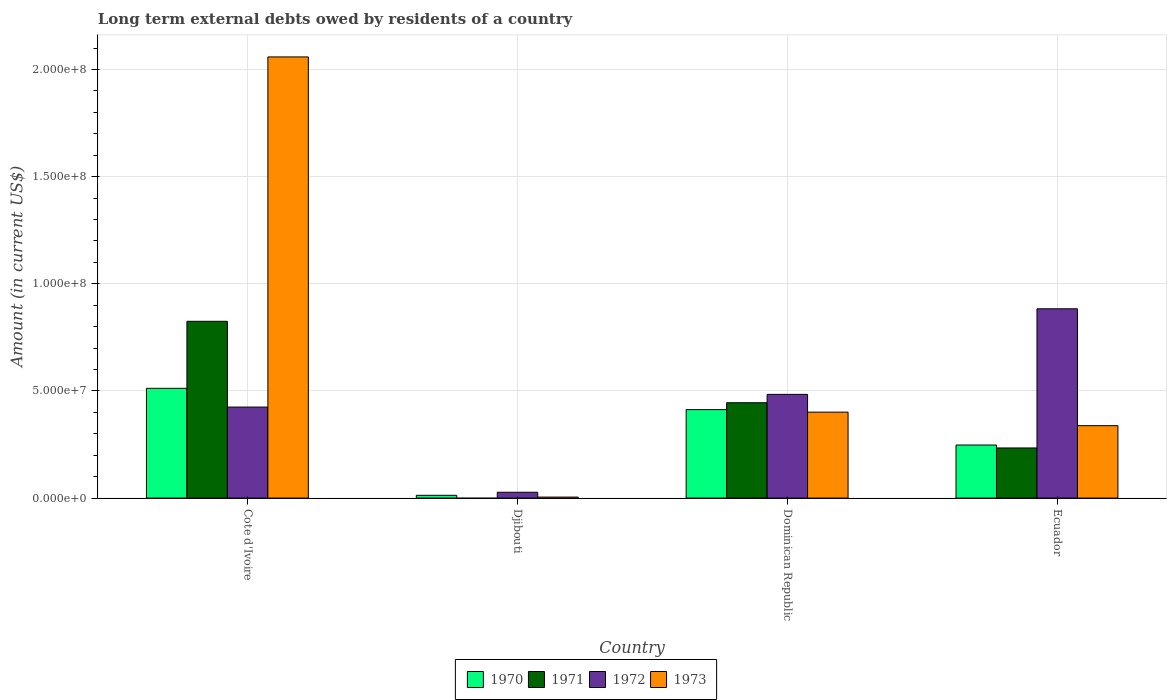Are the number of bars per tick equal to the number of legend labels?
Provide a succinct answer. No. What is the label of the 1st group of bars from the left?
Your answer should be very brief. Cote d'Ivoire. What is the amount of long-term external debts owed by residents in 1973 in Ecuador?
Keep it short and to the point. 3.38e+07. Across all countries, what is the maximum amount of long-term external debts owed by residents in 1971?
Your answer should be compact. 8.25e+07. Across all countries, what is the minimum amount of long-term external debts owed by residents in 1972?
Offer a very short reply. 2.72e+06. In which country was the amount of long-term external debts owed by residents in 1973 maximum?
Provide a short and direct response. Cote d'Ivoire. What is the total amount of long-term external debts owed by residents in 1971 in the graph?
Make the answer very short. 1.50e+08. What is the difference between the amount of long-term external debts owed by residents in 1973 in Cote d'Ivoire and that in Djibouti?
Offer a very short reply. 2.05e+08. What is the difference between the amount of long-term external debts owed by residents in 1972 in Djibouti and the amount of long-term external debts owed by residents in 1970 in Dominican Republic?
Ensure brevity in your answer.  -3.86e+07. What is the average amount of long-term external debts owed by residents in 1970 per country?
Make the answer very short. 2.96e+07. What is the difference between the amount of long-term external debts owed by residents of/in 1970 and amount of long-term external debts owed by residents of/in 1973 in Djibouti?
Make the answer very short. 8.32e+05. What is the ratio of the amount of long-term external debts owed by residents in 1973 in Dominican Republic to that in Ecuador?
Provide a succinct answer. 1.19. Is the difference between the amount of long-term external debts owed by residents in 1970 in Cote d'Ivoire and Djibouti greater than the difference between the amount of long-term external debts owed by residents in 1973 in Cote d'Ivoire and Djibouti?
Your answer should be very brief. No. What is the difference between the highest and the second highest amount of long-term external debts owed by residents in 1971?
Offer a very short reply. 5.91e+07. What is the difference between the highest and the lowest amount of long-term external debts owed by residents in 1970?
Give a very brief answer. 4.99e+07. Is the sum of the amount of long-term external debts owed by residents in 1970 in Djibouti and Dominican Republic greater than the maximum amount of long-term external debts owed by residents in 1971 across all countries?
Offer a very short reply. No. How many bars are there?
Your answer should be compact. 15. Are all the bars in the graph horizontal?
Offer a very short reply. No. How many countries are there in the graph?
Your answer should be compact. 4. What is the difference between two consecutive major ticks on the Y-axis?
Offer a very short reply. 5.00e+07. Are the values on the major ticks of Y-axis written in scientific E-notation?
Keep it short and to the point. Yes. Does the graph contain any zero values?
Your answer should be compact. Yes. Does the graph contain grids?
Provide a short and direct response. Yes. How are the legend labels stacked?
Give a very brief answer. Horizontal. What is the title of the graph?
Provide a short and direct response. Long term external debts owed by residents of a country. Does "2004" appear as one of the legend labels in the graph?
Provide a short and direct response. No. What is the label or title of the X-axis?
Keep it short and to the point. Country. What is the Amount (in current US$) of 1970 in Cote d'Ivoire?
Your answer should be compact. 5.12e+07. What is the Amount (in current US$) in 1971 in Cote d'Ivoire?
Provide a succinct answer. 8.25e+07. What is the Amount (in current US$) of 1972 in Cote d'Ivoire?
Keep it short and to the point. 4.25e+07. What is the Amount (in current US$) in 1973 in Cote d'Ivoire?
Provide a succinct answer. 2.06e+08. What is the Amount (in current US$) of 1970 in Djibouti?
Your response must be concise. 1.30e+06. What is the Amount (in current US$) in 1971 in Djibouti?
Offer a terse response. 0. What is the Amount (in current US$) in 1972 in Djibouti?
Provide a short and direct response. 2.72e+06. What is the Amount (in current US$) of 1973 in Djibouti?
Provide a short and direct response. 4.68e+05. What is the Amount (in current US$) of 1970 in Dominican Republic?
Your answer should be compact. 4.13e+07. What is the Amount (in current US$) of 1971 in Dominican Republic?
Your response must be concise. 4.45e+07. What is the Amount (in current US$) in 1972 in Dominican Republic?
Ensure brevity in your answer.  4.84e+07. What is the Amount (in current US$) of 1973 in Dominican Republic?
Offer a terse response. 4.01e+07. What is the Amount (in current US$) of 1970 in Ecuador?
Ensure brevity in your answer.  2.48e+07. What is the Amount (in current US$) in 1971 in Ecuador?
Offer a terse response. 2.34e+07. What is the Amount (in current US$) in 1972 in Ecuador?
Your answer should be compact. 8.83e+07. What is the Amount (in current US$) in 1973 in Ecuador?
Provide a succinct answer. 3.38e+07. Across all countries, what is the maximum Amount (in current US$) of 1970?
Offer a terse response. 5.12e+07. Across all countries, what is the maximum Amount (in current US$) in 1971?
Your answer should be very brief. 8.25e+07. Across all countries, what is the maximum Amount (in current US$) of 1972?
Offer a terse response. 8.83e+07. Across all countries, what is the maximum Amount (in current US$) in 1973?
Keep it short and to the point. 2.06e+08. Across all countries, what is the minimum Amount (in current US$) in 1970?
Make the answer very short. 1.30e+06. Across all countries, what is the minimum Amount (in current US$) of 1972?
Give a very brief answer. 2.72e+06. Across all countries, what is the minimum Amount (in current US$) in 1973?
Make the answer very short. 4.68e+05. What is the total Amount (in current US$) in 1970 in the graph?
Keep it short and to the point. 1.19e+08. What is the total Amount (in current US$) in 1971 in the graph?
Your answer should be compact. 1.50e+08. What is the total Amount (in current US$) in 1972 in the graph?
Offer a very short reply. 1.82e+08. What is the total Amount (in current US$) in 1973 in the graph?
Offer a terse response. 2.80e+08. What is the difference between the Amount (in current US$) of 1970 in Cote d'Ivoire and that in Djibouti?
Make the answer very short. 4.99e+07. What is the difference between the Amount (in current US$) in 1972 in Cote d'Ivoire and that in Djibouti?
Provide a short and direct response. 3.98e+07. What is the difference between the Amount (in current US$) of 1973 in Cote d'Ivoire and that in Djibouti?
Make the answer very short. 2.05e+08. What is the difference between the Amount (in current US$) of 1970 in Cote d'Ivoire and that in Dominican Republic?
Give a very brief answer. 9.93e+06. What is the difference between the Amount (in current US$) in 1971 in Cote d'Ivoire and that in Dominican Republic?
Offer a very short reply. 3.80e+07. What is the difference between the Amount (in current US$) of 1972 in Cote d'Ivoire and that in Dominican Republic?
Keep it short and to the point. -5.92e+06. What is the difference between the Amount (in current US$) of 1973 in Cote d'Ivoire and that in Dominican Republic?
Your response must be concise. 1.66e+08. What is the difference between the Amount (in current US$) of 1970 in Cote d'Ivoire and that in Ecuador?
Your response must be concise. 2.65e+07. What is the difference between the Amount (in current US$) of 1971 in Cote d'Ivoire and that in Ecuador?
Provide a succinct answer. 5.91e+07. What is the difference between the Amount (in current US$) in 1972 in Cote d'Ivoire and that in Ecuador?
Provide a short and direct response. -4.59e+07. What is the difference between the Amount (in current US$) in 1973 in Cote d'Ivoire and that in Ecuador?
Provide a short and direct response. 1.72e+08. What is the difference between the Amount (in current US$) in 1970 in Djibouti and that in Dominican Republic?
Provide a short and direct response. -4.00e+07. What is the difference between the Amount (in current US$) of 1972 in Djibouti and that in Dominican Republic?
Make the answer very short. -4.57e+07. What is the difference between the Amount (in current US$) of 1973 in Djibouti and that in Dominican Republic?
Your response must be concise. -3.96e+07. What is the difference between the Amount (in current US$) in 1970 in Djibouti and that in Ecuador?
Your answer should be compact. -2.35e+07. What is the difference between the Amount (in current US$) in 1972 in Djibouti and that in Ecuador?
Your answer should be compact. -8.56e+07. What is the difference between the Amount (in current US$) of 1973 in Djibouti and that in Ecuador?
Keep it short and to the point. -3.33e+07. What is the difference between the Amount (in current US$) in 1970 in Dominican Republic and that in Ecuador?
Provide a succinct answer. 1.65e+07. What is the difference between the Amount (in current US$) of 1971 in Dominican Republic and that in Ecuador?
Provide a succinct answer. 2.11e+07. What is the difference between the Amount (in current US$) in 1972 in Dominican Republic and that in Ecuador?
Provide a short and direct response. -3.99e+07. What is the difference between the Amount (in current US$) of 1973 in Dominican Republic and that in Ecuador?
Your answer should be compact. 6.31e+06. What is the difference between the Amount (in current US$) in 1970 in Cote d'Ivoire and the Amount (in current US$) in 1972 in Djibouti?
Your answer should be very brief. 4.85e+07. What is the difference between the Amount (in current US$) in 1970 in Cote d'Ivoire and the Amount (in current US$) in 1973 in Djibouti?
Keep it short and to the point. 5.08e+07. What is the difference between the Amount (in current US$) in 1971 in Cote d'Ivoire and the Amount (in current US$) in 1972 in Djibouti?
Provide a succinct answer. 7.98e+07. What is the difference between the Amount (in current US$) of 1971 in Cote d'Ivoire and the Amount (in current US$) of 1973 in Djibouti?
Your response must be concise. 8.20e+07. What is the difference between the Amount (in current US$) of 1972 in Cote d'Ivoire and the Amount (in current US$) of 1973 in Djibouti?
Ensure brevity in your answer.  4.20e+07. What is the difference between the Amount (in current US$) in 1970 in Cote d'Ivoire and the Amount (in current US$) in 1971 in Dominican Republic?
Keep it short and to the point. 6.73e+06. What is the difference between the Amount (in current US$) of 1970 in Cote d'Ivoire and the Amount (in current US$) of 1972 in Dominican Republic?
Keep it short and to the point. 2.83e+06. What is the difference between the Amount (in current US$) of 1970 in Cote d'Ivoire and the Amount (in current US$) of 1973 in Dominican Republic?
Offer a terse response. 1.11e+07. What is the difference between the Amount (in current US$) of 1971 in Cote d'Ivoire and the Amount (in current US$) of 1972 in Dominican Republic?
Offer a terse response. 3.41e+07. What is the difference between the Amount (in current US$) in 1971 in Cote d'Ivoire and the Amount (in current US$) in 1973 in Dominican Republic?
Make the answer very short. 4.24e+07. What is the difference between the Amount (in current US$) in 1972 in Cote d'Ivoire and the Amount (in current US$) in 1973 in Dominican Republic?
Make the answer very short. 2.37e+06. What is the difference between the Amount (in current US$) of 1970 in Cote d'Ivoire and the Amount (in current US$) of 1971 in Ecuador?
Your answer should be compact. 2.78e+07. What is the difference between the Amount (in current US$) in 1970 in Cote d'Ivoire and the Amount (in current US$) in 1972 in Ecuador?
Your answer should be very brief. -3.71e+07. What is the difference between the Amount (in current US$) in 1970 in Cote d'Ivoire and the Amount (in current US$) in 1973 in Ecuador?
Keep it short and to the point. 1.74e+07. What is the difference between the Amount (in current US$) of 1971 in Cote d'Ivoire and the Amount (in current US$) of 1972 in Ecuador?
Your response must be concise. -5.84e+06. What is the difference between the Amount (in current US$) in 1971 in Cote d'Ivoire and the Amount (in current US$) in 1973 in Ecuador?
Keep it short and to the point. 4.87e+07. What is the difference between the Amount (in current US$) of 1972 in Cote d'Ivoire and the Amount (in current US$) of 1973 in Ecuador?
Your answer should be compact. 8.68e+06. What is the difference between the Amount (in current US$) in 1970 in Djibouti and the Amount (in current US$) in 1971 in Dominican Republic?
Give a very brief answer. -4.32e+07. What is the difference between the Amount (in current US$) in 1970 in Djibouti and the Amount (in current US$) in 1972 in Dominican Republic?
Give a very brief answer. -4.71e+07. What is the difference between the Amount (in current US$) in 1970 in Djibouti and the Amount (in current US$) in 1973 in Dominican Republic?
Your answer should be compact. -3.88e+07. What is the difference between the Amount (in current US$) of 1972 in Djibouti and the Amount (in current US$) of 1973 in Dominican Republic?
Ensure brevity in your answer.  -3.74e+07. What is the difference between the Amount (in current US$) of 1970 in Djibouti and the Amount (in current US$) of 1971 in Ecuador?
Provide a succinct answer. -2.21e+07. What is the difference between the Amount (in current US$) in 1970 in Djibouti and the Amount (in current US$) in 1972 in Ecuador?
Keep it short and to the point. -8.70e+07. What is the difference between the Amount (in current US$) in 1970 in Djibouti and the Amount (in current US$) in 1973 in Ecuador?
Your response must be concise. -3.25e+07. What is the difference between the Amount (in current US$) of 1972 in Djibouti and the Amount (in current US$) of 1973 in Ecuador?
Keep it short and to the point. -3.11e+07. What is the difference between the Amount (in current US$) of 1970 in Dominican Republic and the Amount (in current US$) of 1971 in Ecuador?
Make the answer very short. 1.79e+07. What is the difference between the Amount (in current US$) of 1970 in Dominican Republic and the Amount (in current US$) of 1972 in Ecuador?
Give a very brief answer. -4.70e+07. What is the difference between the Amount (in current US$) of 1970 in Dominican Republic and the Amount (in current US$) of 1973 in Ecuador?
Give a very brief answer. 7.50e+06. What is the difference between the Amount (in current US$) in 1971 in Dominican Republic and the Amount (in current US$) in 1972 in Ecuador?
Offer a very short reply. -4.38e+07. What is the difference between the Amount (in current US$) in 1971 in Dominican Republic and the Amount (in current US$) in 1973 in Ecuador?
Your response must be concise. 1.07e+07. What is the difference between the Amount (in current US$) of 1972 in Dominican Republic and the Amount (in current US$) of 1973 in Ecuador?
Keep it short and to the point. 1.46e+07. What is the average Amount (in current US$) in 1970 per country?
Your response must be concise. 2.96e+07. What is the average Amount (in current US$) of 1971 per country?
Provide a short and direct response. 3.76e+07. What is the average Amount (in current US$) of 1972 per country?
Make the answer very short. 4.55e+07. What is the average Amount (in current US$) of 1973 per country?
Your answer should be very brief. 7.01e+07. What is the difference between the Amount (in current US$) of 1970 and Amount (in current US$) of 1971 in Cote d'Ivoire?
Provide a succinct answer. -3.13e+07. What is the difference between the Amount (in current US$) of 1970 and Amount (in current US$) of 1972 in Cote d'Ivoire?
Your response must be concise. 8.75e+06. What is the difference between the Amount (in current US$) in 1970 and Amount (in current US$) in 1973 in Cote d'Ivoire?
Ensure brevity in your answer.  -1.55e+08. What is the difference between the Amount (in current US$) in 1971 and Amount (in current US$) in 1972 in Cote d'Ivoire?
Offer a very short reply. 4.00e+07. What is the difference between the Amount (in current US$) in 1971 and Amount (in current US$) in 1973 in Cote d'Ivoire?
Your answer should be very brief. -1.23e+08. What is the difference between the Amount (in current US$) in 1972 and Amount (in current US$) in 1973 in Cote d'Ivoire?
Your response must be concise. -1.63e+08. What is the difference between the Amount (in current US$) in 1970 and Amount (in current US$) in 1972 in Djibouti?
Make the answer very short. -1.42e+06. What is the difference between the Amount (in current US$) in 1970 and Amount (in current US$) in 1973 in Djibouti?
Ensure brevity in your answer.  8.32e+05. What is the difference between the Amount (in current US$) of 1972 and Amount (in current US$) of 1973 in Djibouti?
Your answer should be very brief. 2.26e+06. What is the difference between the Amount (in current US$) in 1970 and Amount (in current US$) in 1971 in Dominican Republic?
Make the answer very short. -3.21e+06. What is the difference between the Amount (in current US$) of 1970 and Amount (in current US$) of 1972 in Dominican Republic?
Ensure brevity in your answer.  -7.11e+06. What is the difference between the Amount (in current US$) of 1970 and Amount (in current US$) of 1973 in Dominican Republic?
Keep it short and to the point. 1.19e+06. What is the difference between the Amount (in current US$) in 1971 and Amount (in current US$) in 1972 in Dominican Republic?
Provide a succinct answer. -3.90e+06. What is the difference between the Amount (in current US$) of 1971 and Amount (in current US$) of 1973 in Dominican Republic?
Your answer should be compact. 4.39e+06. What is the difference between the Amount (in current US$) of 1972 and Amount (in current US$) of 1973 in Dominican Republic?
Your answer should be very brief. 8.29e+06. What is the difference between the Amount (in current US$) in 1970 and Amount (in current US$) in 1971 in Ecuador?
Give a very brief answer. 1.37e+06. What is the difference between the Amount (in current US$) in 1970 and Amount (in current US$) in 1972 in Ecuador?
Your answer should be very brief. -6.36e+07. What is the difference between the Amount (in current US$) in 1970 and Amount (in current US$) in 1973 in Ecuador?
Make the answer very short. -9.03e+06. What is the difference between the Amount (in current US$) in 1971 and Amount (in current US$) in 1972 in Ecuador?
Your answer should be compact. -6.49e+07. What is the difference between the Amount (in current US$) of 1971 and Amount (in current US$) of 1973 in Ecuador?
Make the answer very short. -1.04e+07. What is the difference between the Amount (in current US$) of 1972 and Amount (in current US$) of 1973 in Ecuador?
Provide a succinct answer. 5.45e+07. What is the ratio of the Amount (in current US$) of 1970 in Cote d'Ivoire to that in Djibouti?
Offer a terse response. 39.4. What is the ratio of the Amount (in current US$) in 1972 in Cote d'Ivoire to that in Djibouti?
Offer a very short reply. 15.6. What is the ratio of the Amount (in current US$) of 1973 in Cote d'Ivoire to that in Djibouti?
Offer a very short reply. 439.86. What is the ratio of the Amount (in current US$) in 1970 in Cote d'Ivoire to that in Dominican Republic?
Your answer should be compact. 1.24. What is the ratio of the Amount (in current US$) in 1971 in Cote d'Ivoire to that in Dominican Republic?
Make the answer very short. 1.85. What is the ratio of the Amount (in current US$) of 1972 in Cote d'Ivoire to that in Dominican Republic?
Your answer should be compact. 0.88. What is the ratio of the Amount (in current US$) of 1973 in Cote d'Ivoire to that in Dominican Republic?
Provide a short and direct response. 5.13. What is the ratio of the Amount (in current US$) in 1970 in Cote d'Ivoire to that in Ecuador?
Your answer should be very brief. 2.07. What is the ratio of the Amount (in current US$) in 1971 in Cote d'Ivoire to that in Ecuador?
Offer a terse response. 3.53. What is the ratio of the Amount (in current US$) of 1972 in Cote d'Ivoire to that in Ecuador?
Make the answer very short. 0.48. What is the ratio of the Amount (in current US$) in 1973 in Cote d'Ivoire to that in Ecuador?
Give a very brief answer. 6.09. What is the ratio of the Amount (in current US$) of 1970 in Djibouti to that in Dominican Republic?
Keep it short and to the point. 0.03. What is the ratio of the Amount (in current US$) in 1972 in Djibouti to that in Dominican Republic?
Offer a terse response. 0.06. What is the ratio of the Amount (in current US$) in 1973 in Djibouti to that in Dominican Republic?
Make the answer very short. 0.01. What is the ratio of the Amount (in current US$) in 1970 in Djibouti to that in Ecuador?
Your response must be concise. 0.05. What is the ratio of the Amount (in current US$) in 1972 in Djibouti to that in Ecuador?
Make the answer very short. 0.03. What is the ratio of the Amount (in current US$) in 1973 in Djibouti to that in Ecuador?
Offer a terse response. 0.01. What is the ratio of the Amount (in current US$) in 1970 in Dominican Republic to that in Ecuador?
Your answer should be very brief. 1.67. What is the ratio of the Amount (in current US$) in 1971 in Dominican Republic to that in Ecuador?
Offer a very short reply. 1.9. What is the ratio of the Amount (in current US$) in 1972 in Dominican Republic to that in Ecuador?
Your answer should be very brief. 0.55. What is the ratio of the Amount (in current US$) in 1973 in Dominican Republic to that in Ecuador?
Your answer should be very brief. 1.19. What is the difference between the highest and the second highest Amount (in current US$) in 1970?
Make the answer very short. 9.93e+06. What is the difference between the highest and the second highest Amount (in current US$) of 1971?
Your response must be concise. 3.80e+07. What is the difference between the highest and the second highest Amount (in current US$) of 1972?
Provide a succinct answer. 3.99e+07. What is the difference between the highest and the second highest Amount (in current US$) of 1973?
Your answer should be very brief. 1.66e+08. What is the difference between the highest and the lowest Amount (in current US$) in 1970?
Keep it short and to the point. 4.99e+07. What is the difference between the highest and the lowest Amount (in current US$) of 1971?
Your answer should be compact. 8.25e+07. What is the difference between the highest and the lowest Amount (in current US$) of 1972?
Make the answer very short. 8.56e+07. What is the difference between the highest and the lowest Amount (in current US$) of 1973?
Your answer should be compact. 2.05e+08. 